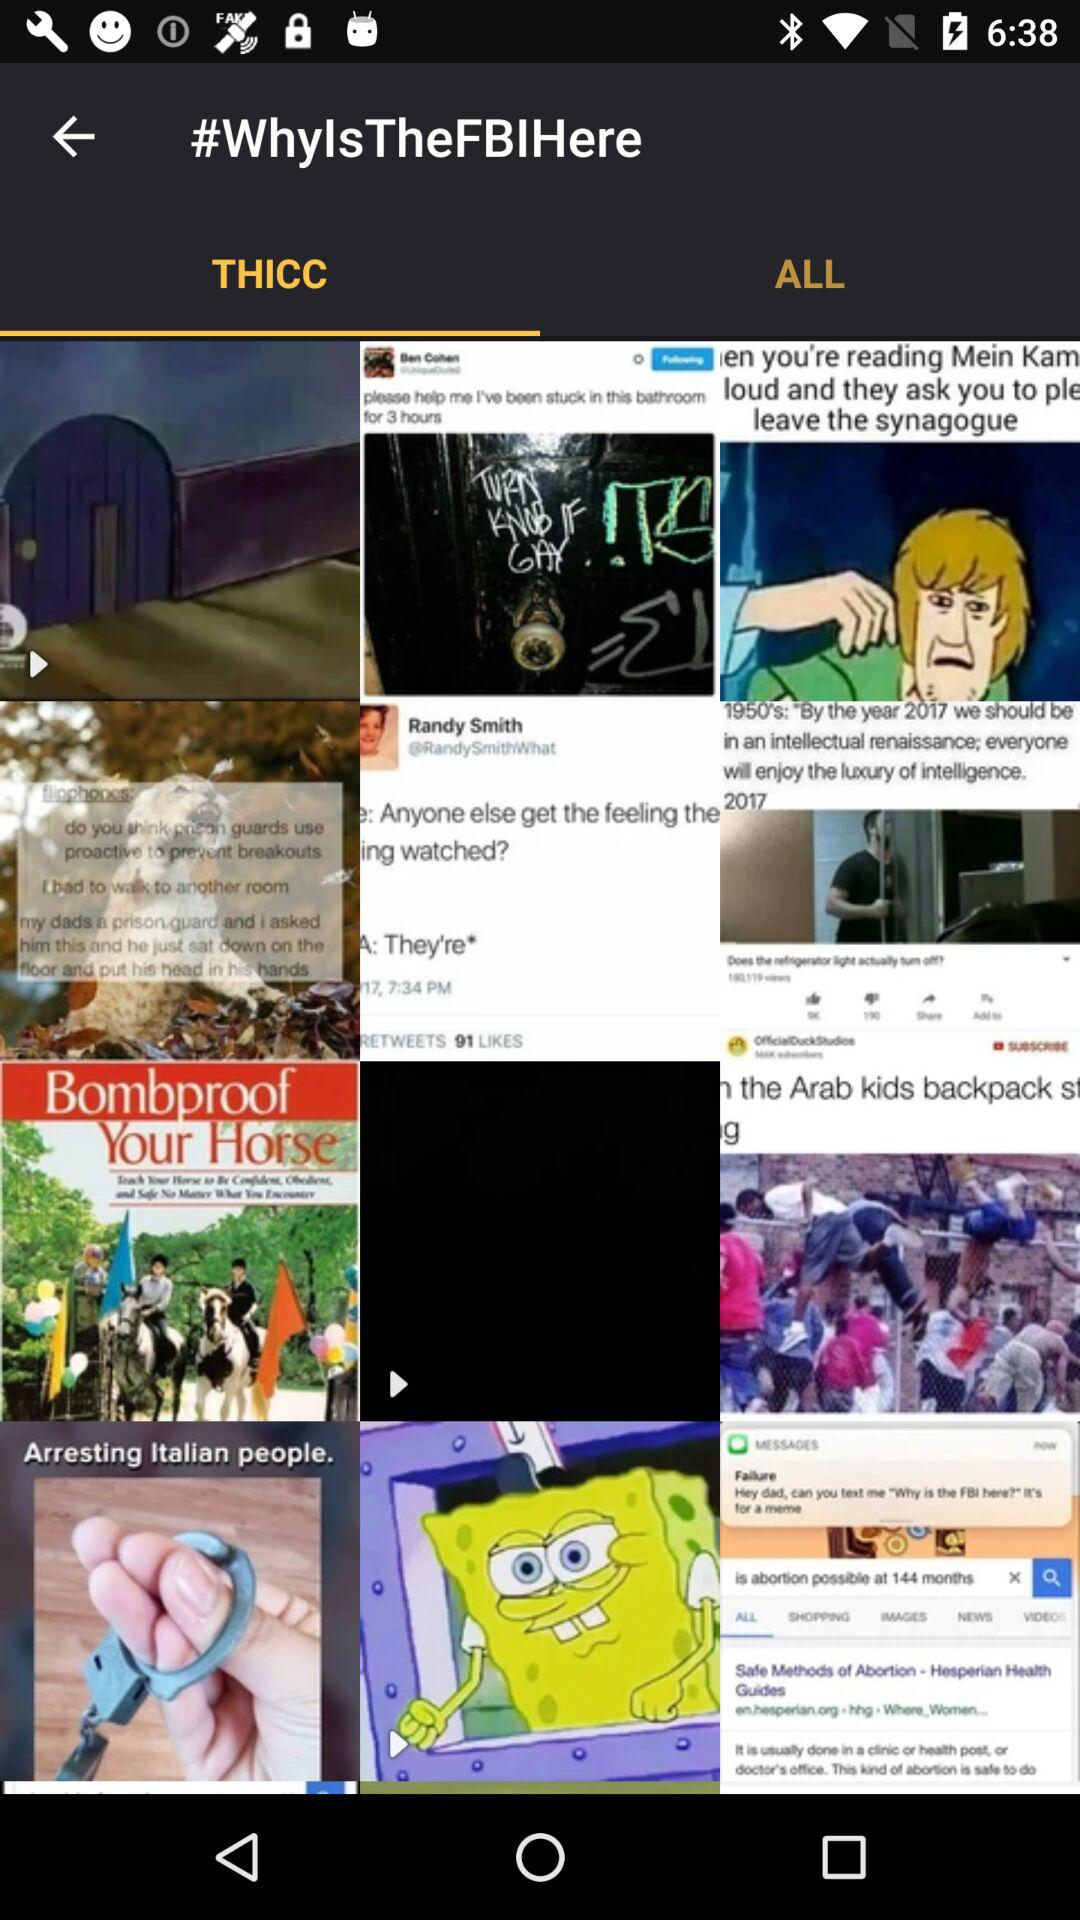Which tab is selected? The selected tab is "THICC". 